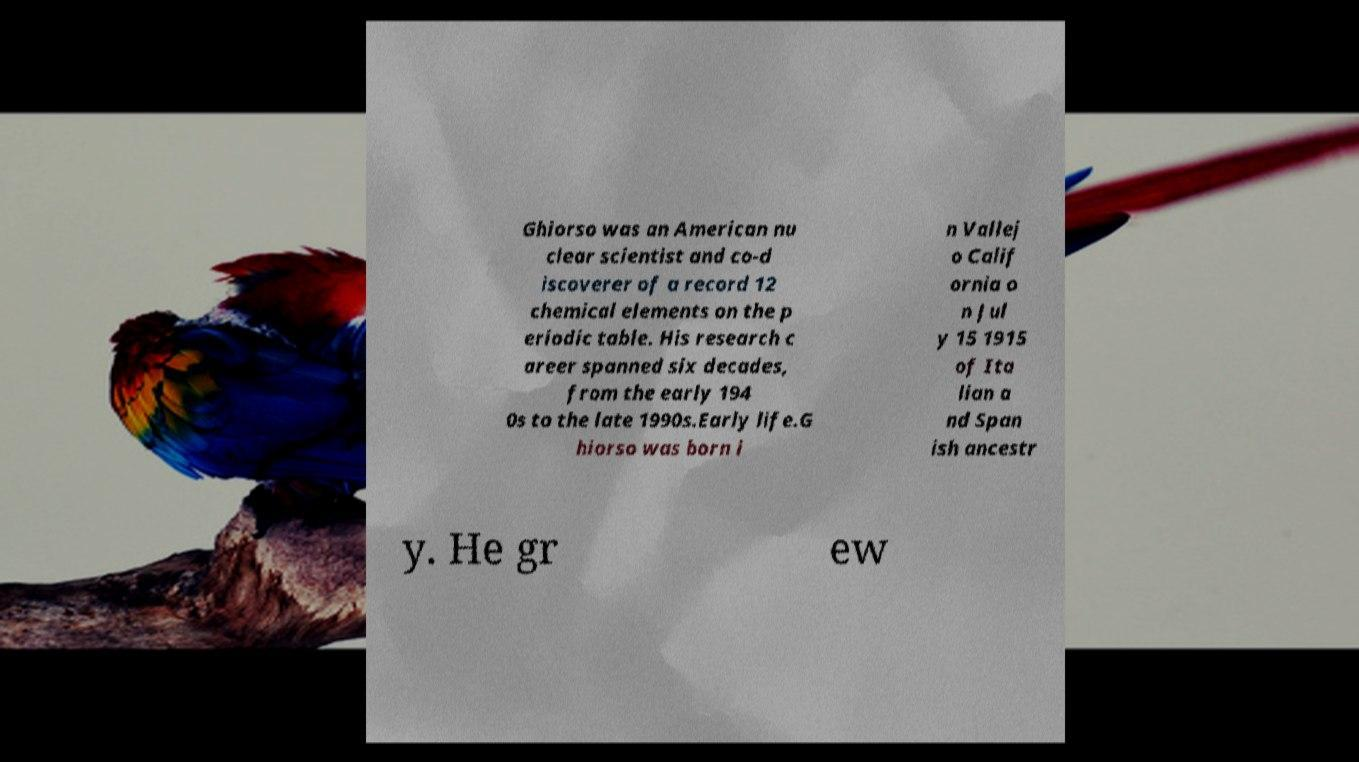Can you accurately transcribe the text from the provided image for me? Ghiorso was an American nu clear scientist and co-d iscoverer of a record 12 chemical elements on the p eriodic table. His research c areer spanned six decades, from the early 194 0s to the late 1990s.Early life.G hiorso was born i n Vallej o Calif ornia o n Jul y 15 1915 of Ita lian a nd Span ish ancestr y. He gr ew 